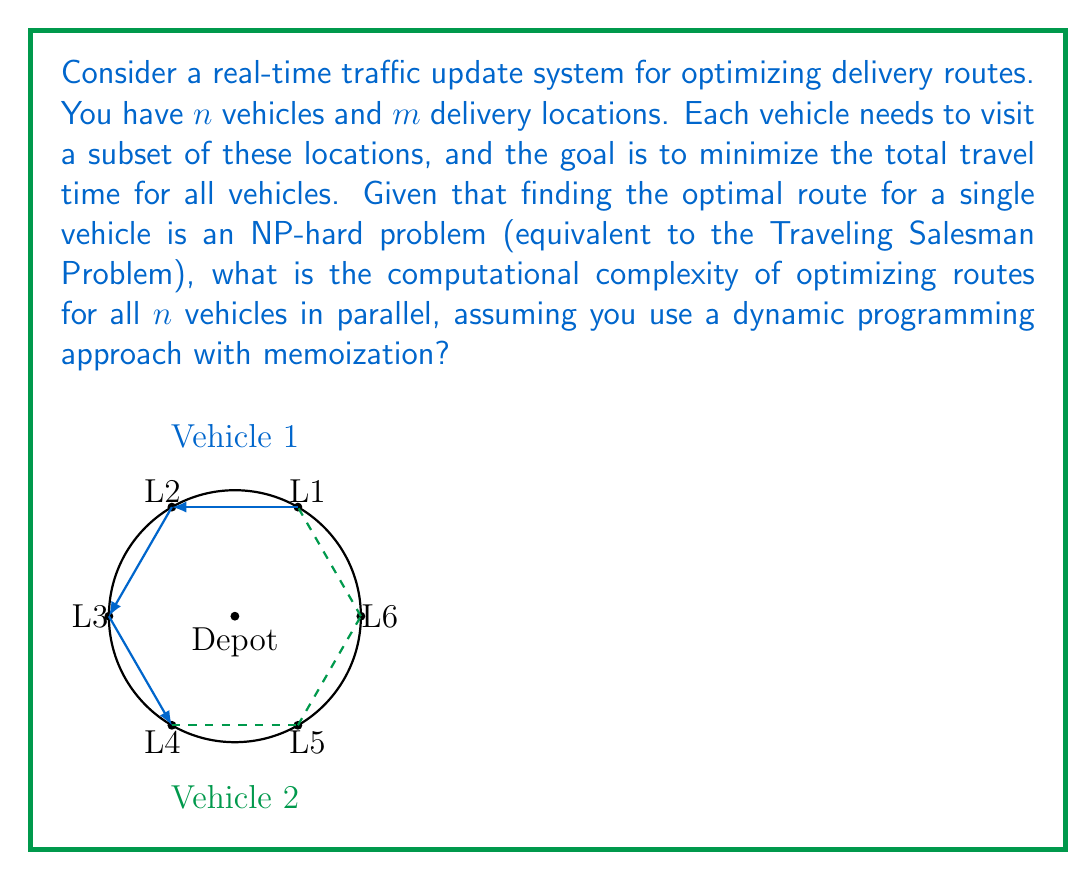Can you solve this math problem? Let's approach this step-by-step:

1) First, recall that the Traveling Salesman Problem (TSP) for a single vehicle with $k$ locations has a time complexity of $O(k^2 2^k)$ using dynamic programming with the Held-Karp algorithm.

2) In our scenario, we have $n$ vehicles, each potentially visiting up to $m$ locations. The worst-case scenario is when each vehicle needs to visit all $m$ locations.

3) For each vehicle, we need to solve a TSP-like problem. The time complexity for one vehicle would be $O(m^2 2^m)$.

4) Since we're optimizing for $n$ vehicles in parallel, we multiply this complexity by $n$:

   $$O(n \cdot m^2 2^m)$$

5) However, we also need to consider the interactions between vehicles. In the worst case, we might need to consider all possible assignments of locations to vehicles. This introduces an additional factor of $m^n$ (each of the $m$ locations could be assigned to any of the $n$ vehicles).

6) Combining these factors, our overall time complexity becomes:

   $$O(n \cdot m^2 2^m \cdot m^n) = O(n \cdot m^{n+2} \cdot 2^m)$$

7) This complexity is exponential in both $m$ and $n$, making it a highly computationally intensive problem for large numbers of vehicles or locations.

8) It's worth noting that this is an upper bound on the complexity. In practice, various heuristics and approximation algorithms are used to make the problem more tractable for real-world applications.
Answer: $O(n \cdot m^{n+2} \cdot 2^m)$ 